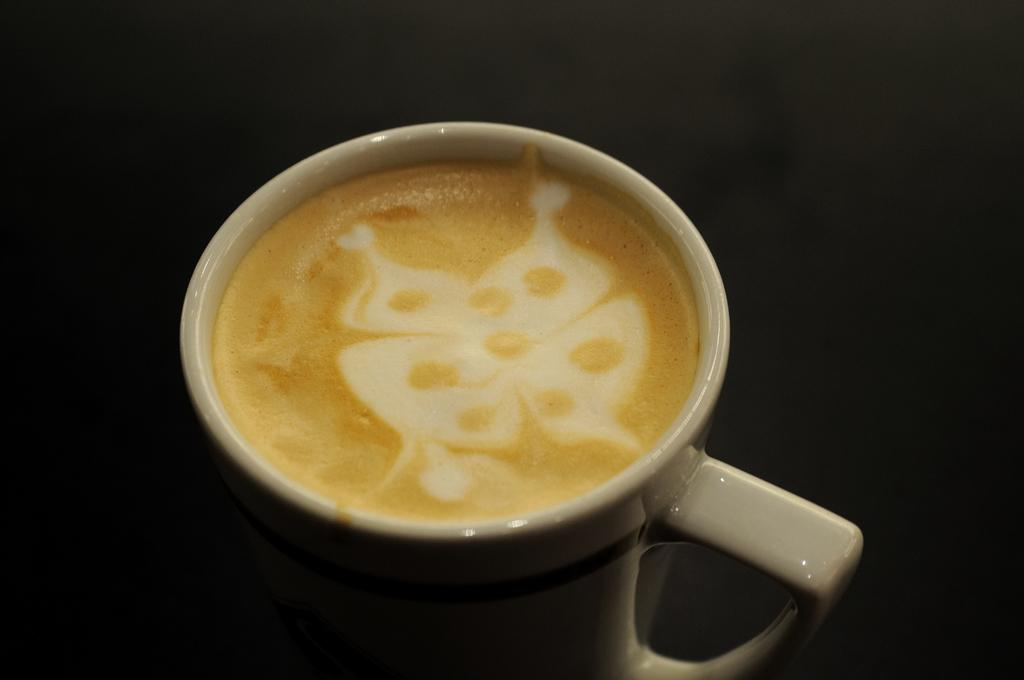What is the main subject in the foreground of the image? There is an office in a cup in the foreground of the image. Can you describe the location of the cup in the image? The cup is on a surface. How many socks are hanging from the icicle in the image? There is no icicle or sock present in the image. 